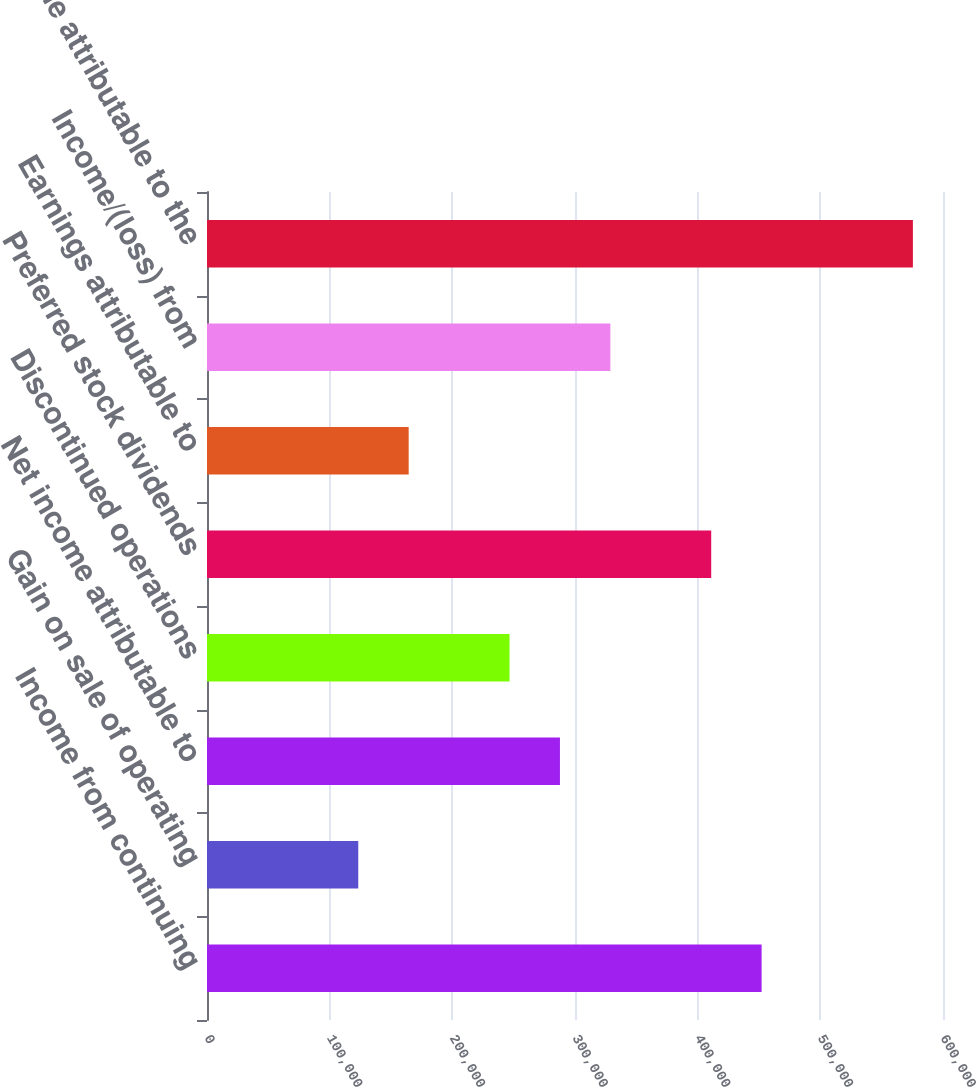<chart> <loc_0><loc_0><loc_500><loc_500><bar_chart><fcel>Income from continuing<fcel>Gain on sale of operating<fcel>Net income attributable to<fcel>Discontinued operations<fcel>Preferred stock dividends<fcel>Earnings attributable to<fcel>Income/(loss) from<fcel>Net income attributable to the<nl><fcel>452142<fcel>123311<fcel>287727<fcel>246623<fcel>411038<fcel>164415<fcel>328830<fcel>575453<nl></chart> 